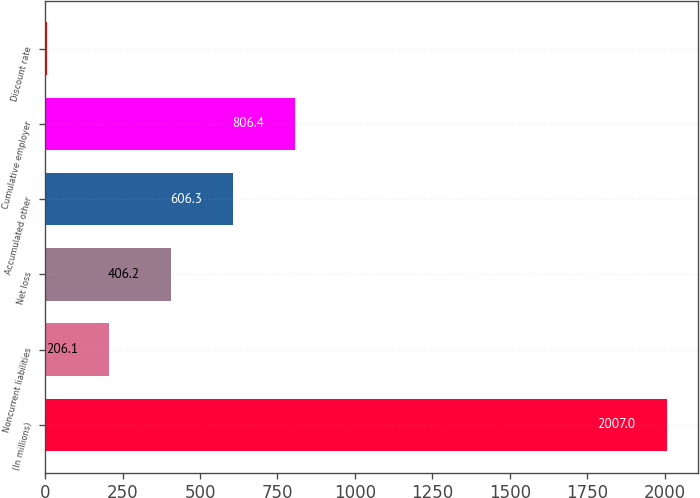Convert chart to OTSL. <chart><loc_0><loc_0><loc_500><loc_500><bar_chart><fcel>(In millions)<fcel>Noncurrent liabilities<fcel>Net loss<fcel>Accumulated other<fcel>Cumulative employer<fcel>Discount rate<nl><fcel>2007<fcel>206.1<fcel>406.2<fcel>606.3<fcel>806.4<fcel>6<nl></chart> 